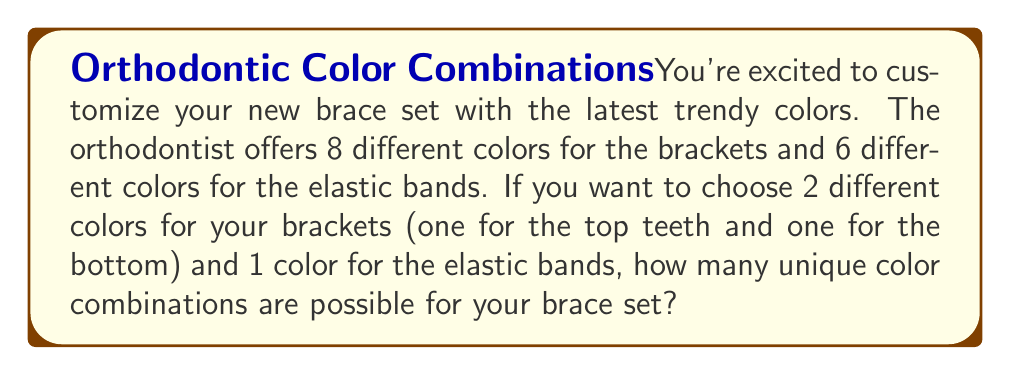Solve this math problem. Let's break this problem down into steps:

1. Choosing colors for brackets:
   - We need to select 2 different colors out of 8 available colors.
   - This is a permutation problem because the order matters (top vs bottom).
   - The number of ways to do this is given by the permutation formula:
     $$P(8,2) = \frac{8!}{(8-2)!} = \frac{8!}{6!} = 8 \times 7 = 56$$

2. Choosing a color for elastic bands:
   - We need to select 1 color out of 6 available colors.
   - This is a simple choice with 6 options.

3. Combining the choices:
   - For each way of choosing bracket colors, we have 6 choices for the elastic band color.
   - We use the multiplication principle to combine these choices.

Therefore, the total number of unique color combinations is:
$$56 \times 6 = 336$$
Answer: 336 unique color combinations 